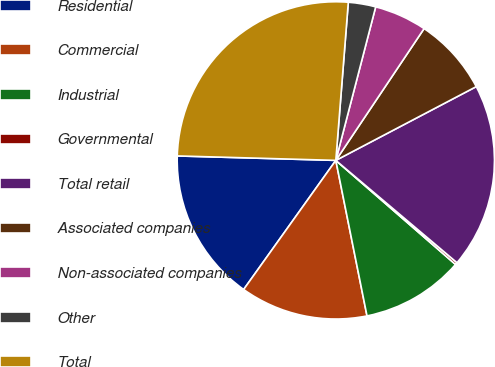Convert chart to OTSL. <chart><loc_0><loc_0><loc_500><loc_500><pie_chart><fcel>Residential<fcel>Commercial<fcel>Industrial<fcel>Governmental<fcel>Total retail<fcel>Associated companies<fcel>Non-associated companies<fcel>Other<fcel>Total<nl><fcel>15.58%<fcel>13.02%<fcel>10.46%<fcel>0.23%<fcel>18.86%<fcel>7.91%<fcel>5.35%<fcel>2.79%<fcel>25.81%<nl></chart> 